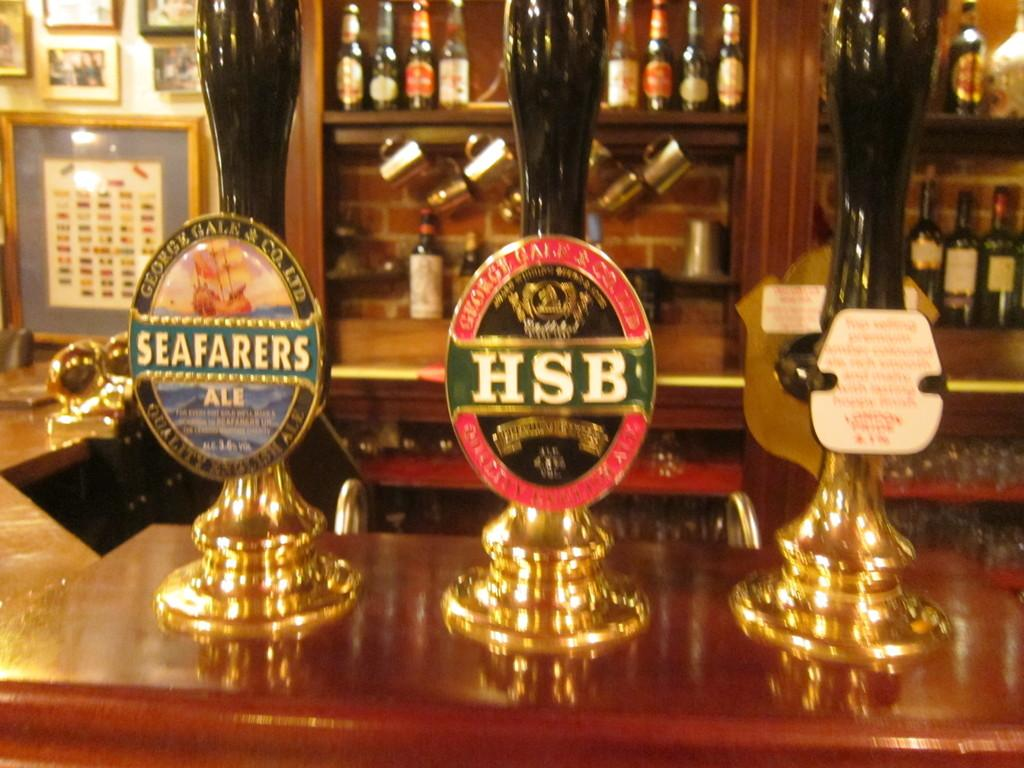Provide a one-sentence caption for the provided image. Three beer taps at a bar with the middle one named "HSB". 